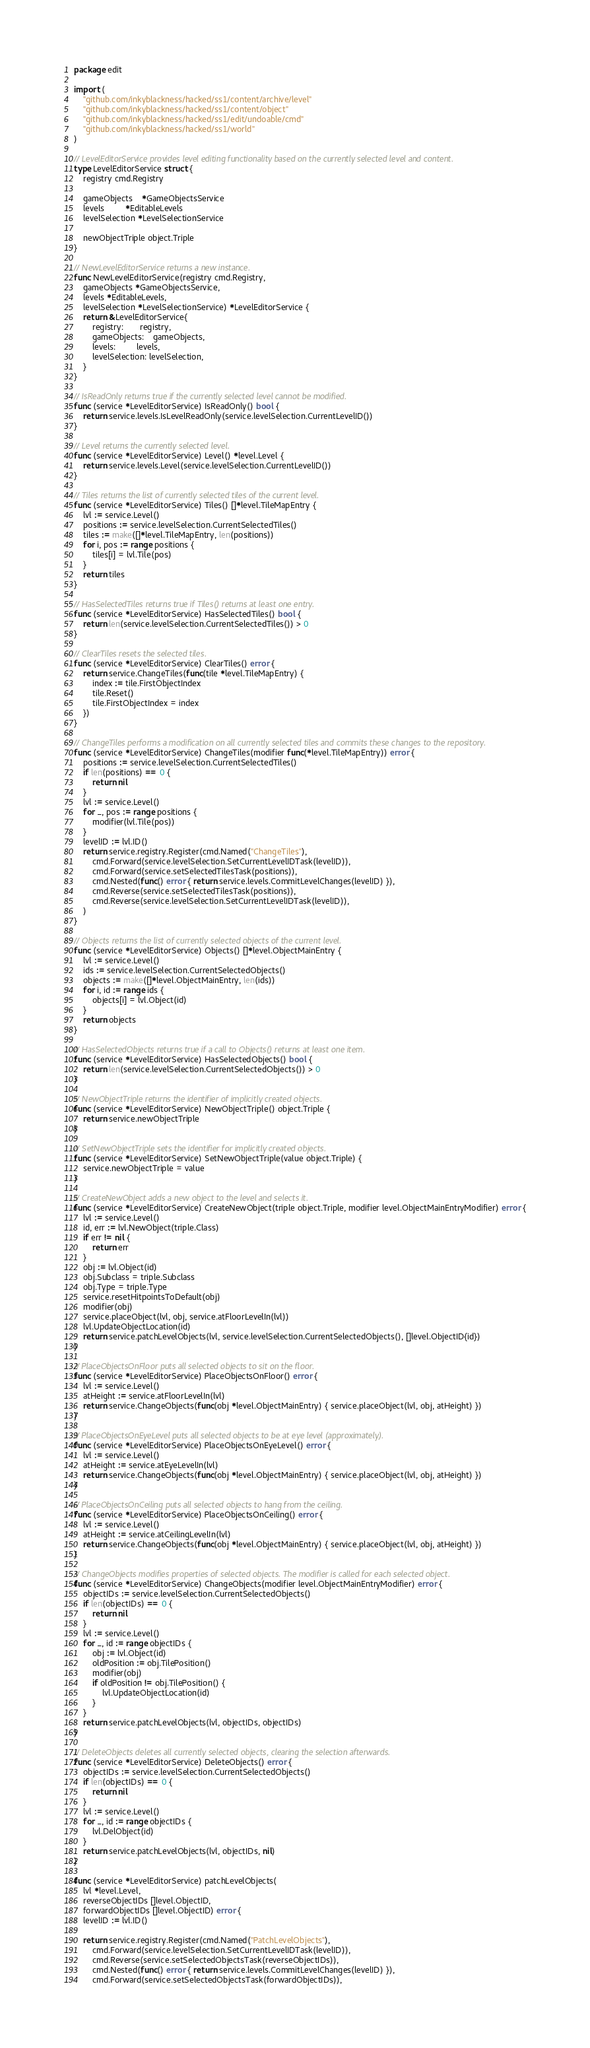Convert code to text. <code><loc_0><loc_0><loc_500><loc_500><_Go_>package edit

import (
	"github.com/inkyblackness/hacked/ss1/content/archive/level"
	"github.com/inkyblackness/hacked/ss1/content/object"
	"github.com/inkyblackness/hacked/ss1/edit/undoable/cmd"
	"github.com/inkyblackness/hacked/ss1/world"
)

// LevelEditorService provides level editing functionality based on the currently selected level and content.
type LevelEditorService struct {
	registry cmd.Registry

	gameObjects    *GameObjectsService
	levels         *EditableLevels
	levelSelection *LevelSelectionService

	newObjectTriple object.Triple
}

// NewLevelEditorService returns a new instance.
func NewLevelEditorService(registry cmd.Registry,
	gameObjects *GameObjectsService,
	levels *EditableLevels,
	levelSelection *LevelSelectionService) *LevelEditorService {
	return &LevelEditorService{
		registry:       registry,
		gameObjects:    gameObjects,
		levels:         levels,
		levelSelection: levelSelection,
	}
}

// IsReadOnly returns true if the currently selected level cannot be modified.
func (service *LevelEditorService) IsReadOnly() bool {
	return service.levels.IsLevelReadOnly(service.levelSelection.CurrentLevelID())
}

// Level returns the currently selected level.
func (service *LevelEditorService) Level() *level.Level {
	return service.levels.Level(service.levelSelection.CurrentLevelID())
}

// Tiles returns the list of currently selected tiles of the current level.
func (service *LevelEditorService) Tiles() []*level.TileMapEntry {
	lvl := service.Level()
	positions := service.levelSelection.CurrentSelectedTiles()
	tiles := make([]*level.TileMapEntry, len(positions))
	for i, pos := range positions {
		tiles[i] = lvl.Tile(pos)
	}
	return tiles
}

// HasSelectedTiles returns true if Tiles() returns at least one entry.
func (service *LevelEditorService) HasSelectedTiles() bool {
	return len(service.levelSelection.CurrentSelectedTiles()) > 0
}

// ClearTiles resets the selected tiles.
func (service *LevelEditorService) ClearTiles() error {
	return service.ChangeTiles(func(tile *level.TileMapEntry) {
		index := tile.FirstObjectIndex
		tile.Reset()
		tile.FirstObjectIndex = index
	})
}

// ChangeTiles performs a modification on all currently selected tiles and commits these changes to the repository.
func (service *LevelEditorService) ChangeTiles(modifier func(*level.TileMapEntry)) error {
	positions := service.levelSelection.CurrentSelectedTiles()
	if len(positions) == 0 {
		return nil
	}
	lvl := service.Level()
	for _, pos := range positions {
		modifier(lvl.Tile(pos))
	}
	levelID := lvl.ID()
	return service.registry.Register(cmd.Named("ChangeTiles"),
		cmd.Forward(service.levelSelection.SetCurrentLevelIDTask(levelID)),
		cmd.Forward(service.setSelectedTilesTask(positions)),
		cmd.Nested(func() error { return service.levels.CommitLevelChanges(levelID) }),
		cmd.Reverse(service.setSelectedTilesTask(positions)),
		cmd.Reverse(service.levelSelection.SetCurrentLevelIDTask(levelID)),
	)
}

// Objects returns the list of currently selected objects of the current level.
func (service *LevelEditorService) Objects() []*level.ObjectMainEntry {
	lvl := service.Level()
	ids := service.levelSelection.CurrentSelectedObjects()
	objects := make([]*level.ObjectMainEntry, len(ids))
	for i, id := range ids {
		objects[i] = lvl.Object(id)
	}
	return objects
}

// HasSelectedObjects returns true if a call to Objects() returns at least one item.
func (service *LevelEditorService) HasSelectedObjects() bool {
	return len(service.levelSelection.CurrentSelectedObjects()) > 0
}

// NewObjectTriple returns the identifier of implicitly created objects.
func (service *LevelEditorService) NewObjectTriple() object.Triple {
	return service.newObjectTriple
}

// SetNewObjectTriple sets the identifier for implicitly created objects.
func (service *LevelEditorService) SetNewObjectTriple(value object.Triple) {
	service.newObjectTriple = value
}

// CreateNewObject adds a new object to the level and selects it.
func (service *LevelEditorService) CreateNewObject(triple object.Triple, modifier level.ObjectMainEntryModifier) error {
	lvl := service.Level()
	id, err := lvl.NewObject(triple.Class)
	if err != nil {
		return err
	}
	obj := lvl.Object(id)
	obj.Subclass = triple.Subclass
	obj.Type = triple.Type
	service.resetHitpointsToDefault(obj)
	modifier(obj)
	service.placeObject(lvl, obj, service.atFloorLevelIn(lvl))
	lvl.UpdateObjectLocation(id)
	return service.patchLevelObjects(lvl, service.levelSelection.CurrentSelectedObjects(), []level.ObjectID{id})
}

// PlaceObjectsOnFloor puts all selected objects to sit on the floor.
func (service *LevelEditorService) PlaceObjectsOnFloor() error {
	lvl := service.Level()
	atHeight := service.atFloorLevelIn(lvl)
	return service.ChangeObjects(func(obj *level.ObjectMainEntry) { service.placeObject(lvl, obj, atHeight) })
}

// PlaceObjectsOnEyeLevel puts all selected objects to be at eye level (approximately).
func (service *LevelEditorService) PlaceObjectsOnEyeLevel() error {
	lvl := service.Level()
	atHeight := service.atEyeLevelIn(lvl)
	return service.ChangeObjects(func(obj *level.ObjectMainEntry) { service.placeObject(lvl, obj, atHeight) })
}

// PlaceObjectsOnCeiling puts all selected objects to hang from the ceiling.
func (service *LevelEditorService) PlaceObjectsOnCeiling() error {
	lvl := service.Level()
	atHeight := service.atCeilingLevelIn(lvl)
	return service.ChangeObjects(func(obj *level.ObjectMainEntry) { service.placeObject(lvl, obj, atHeight) })
}

// ChangeObjects modifies properties of selected objects. The modifier is called for each selected object.
func (service *LevelEditorService) ChangeObjects(modifier level.ObjectMainEntryModifier) error {
	objectIDs := service.levelSelection.CurrentSelectedObjects()
	if len(objectIDs) == 0 {
		return nil
	}
	lvl := service.Level()
	for _, id := range objectIDs {
		obj := lvl.Object(id)
		oldPosition := obj.TilePosition()
		modifier(obj)
		if oldPosition != obj.TilePosition() {
			lvl.UpdateObjectLocation(id)
		}
	}
	return service.patchLevelObjects(lvl, objectIDs, objectIDs)
}

// DeleteObjects deletes all currently selected objects, clearing the selection afterwards.
func (service *LevelEditorService) DeleteObjects() error {
	objectIDs := service.levelSelection.CurrentSelectedObjects()
	if len(objectIDs) == 0 {
		return nil
	}
	lvl := service.Level()
	for _, id := range objectIDs {
		lvl.DelObject(id)
	}
	return service.patchLevelObjects(lvl, objectIDs, nil)
}

func (service *LevelEditorService) patchLevelObjects(
	lvl *level.Level,
	reverseObjectIDs []level.ObjectID,
	forwardObjectIDs []level.ObjectID) error {
	levelID := lvl.ID()

	return service.registry.Register(cmd.Named("PatchLevelObjects"),
		cmd.Forward(service.levelSelection.SetCurrentLevelIDTask(levelID)),
		cmd.Reverse(service.setSelectedObjectsTask(reverseObjectIDs)),
		cmd.Nested(func() error { return service.levels.CommitLevelChanges(levelID) }),
		cmd.Forward(service.setSelectedObjectsTask(forwardObjectIDs)),</code> 